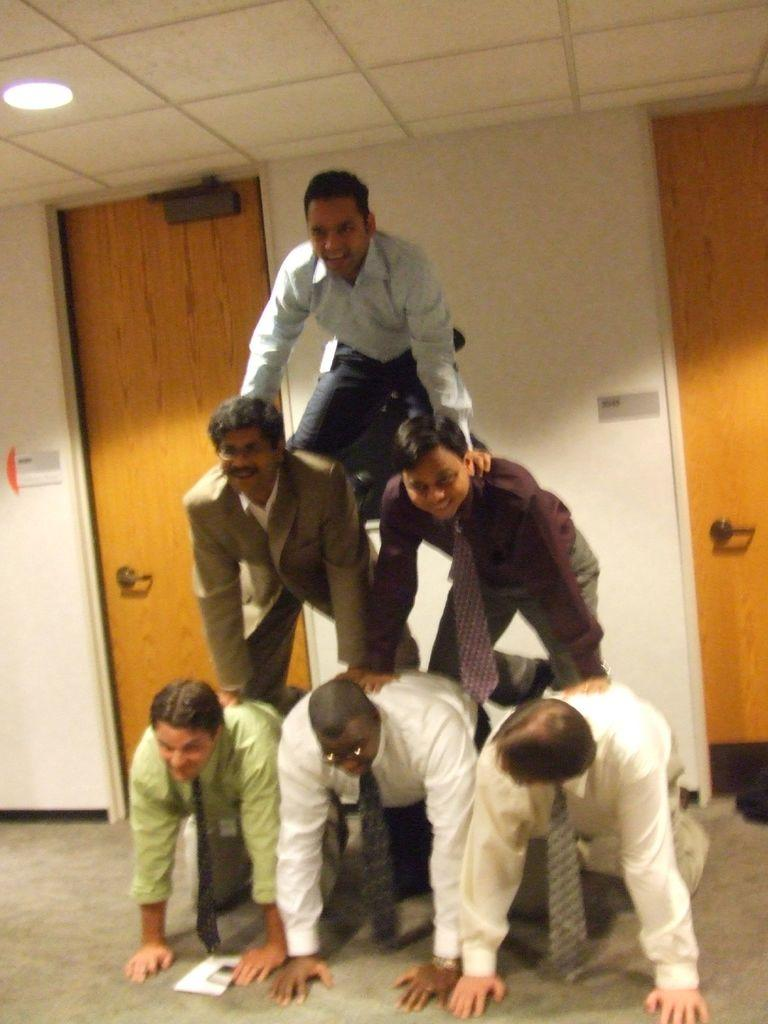What is the main subject of the image? There is a human pyramid in the image. What can be seen in the background of the image? There are two doors and a wall in the background of the image. Can you describe the lighting in the image? There is a light attached to the roof on the left side of the image. What type of slope can be seen in the image? There is no slope present in the image. Can you describe the sponge used by the participants in the human pyramid? There is no sponge mentioned or visible in the image. 